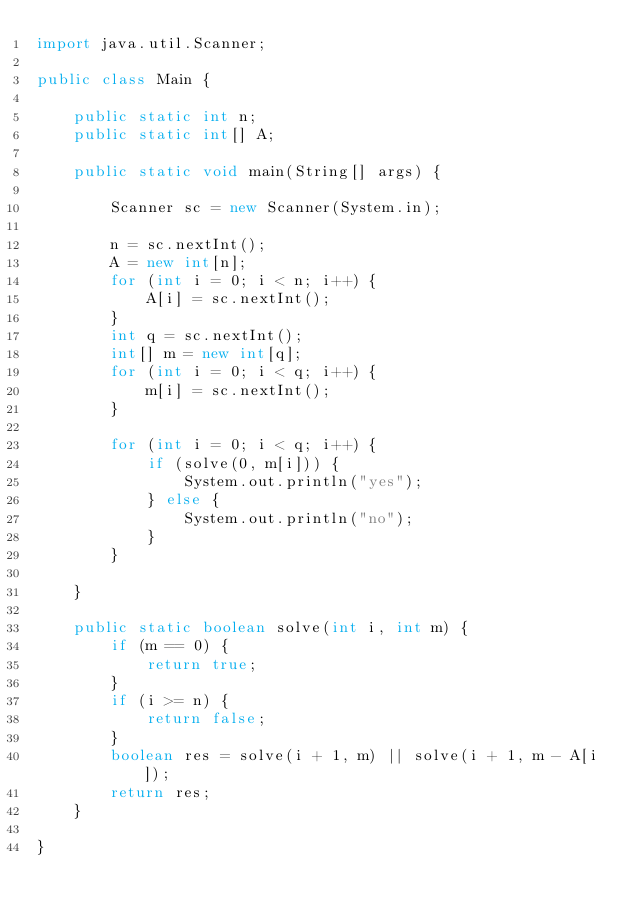<code> <loc_0><loc_0><loc_500><loc_500><_Java_>import java.util.Scanner;

public class Main {

	public static int n;
	public static int[] A;

	public static void main(String[] args) {

		Scanner sc = new Scanner(System.in);

		n = sc.nextInt();
		A = new int[n];
		for (int i = 0; i < n; i++) {
			A[i] = sc.nextInt();
		}
		int q = sc.nextInt();
		int[] m = new int[q];
		for (int i = 0; i < q; i++) {
			m[i] = sc.nextInt();
		}

		for (int i = 0; i < q; i++) {
			if (solve(0, m[i])) {
				System.out.println("yes");
			} else {
				System.out.println("no");
			}
		}

	}

	public static boolean solve(int i, int m) {
		if (m == 0) {
			return true;
		}
		if (i >= n) {
			return false;
		}
		boolean res = solve(i + 1, m) || solve(i + 1, m - A[i]);
		return res;
	}

}
</code> 